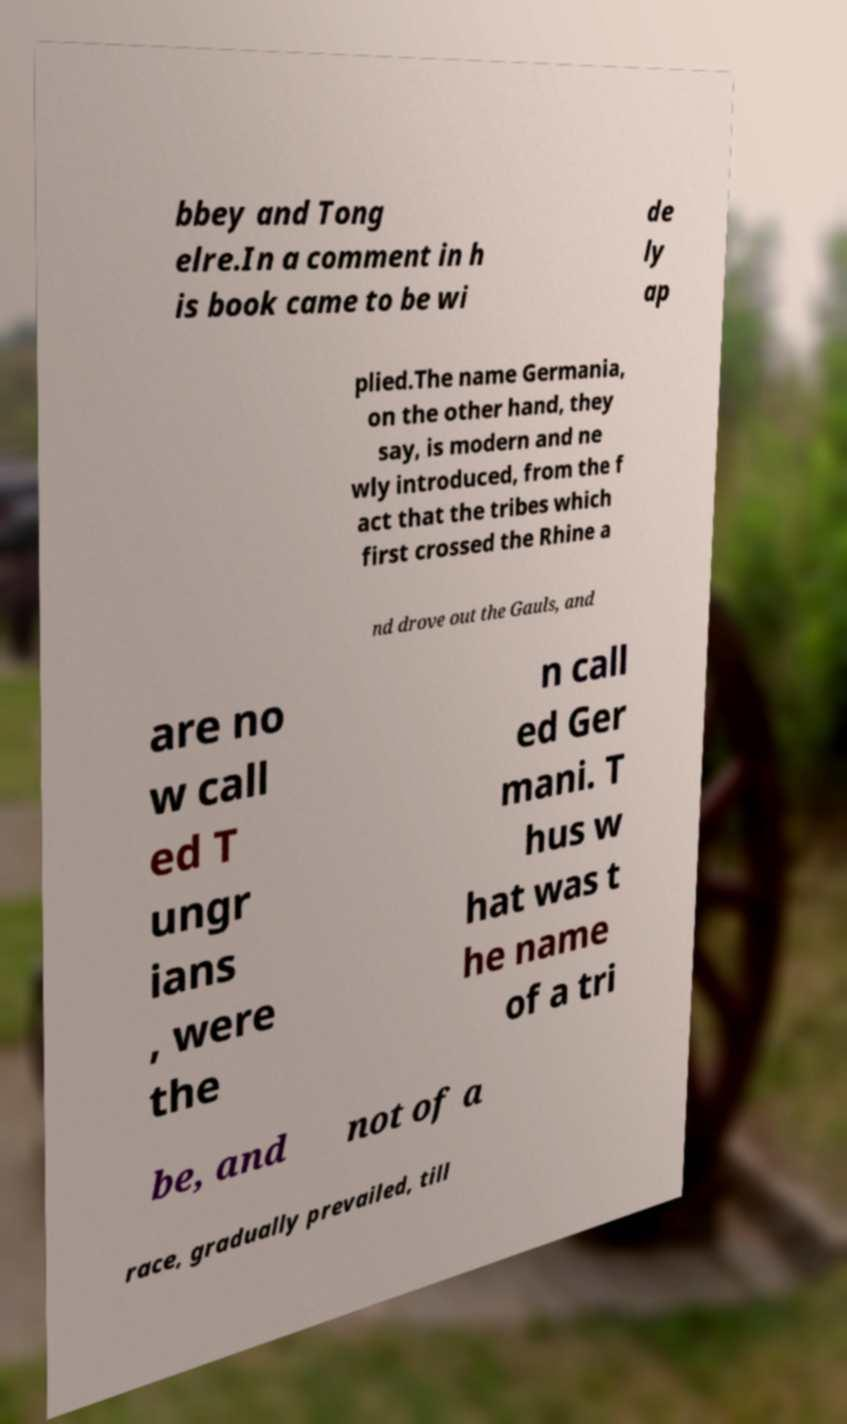Please read and relay the text visible in this image. What does it say? bbey and Tong elre.In a comment in h is book came to be wi de ly ap plied.The name Germania, on the other hand, they say, is modern and ne wly introduced, from the f act that the tribes which first crossed the Rhine a nd drove out the Gauls, and are no w call ed T ungr ians , were the n call ed Ger mani. T hus w hat was t he name of a tri be, and not of a race, gradually prevailed, till 